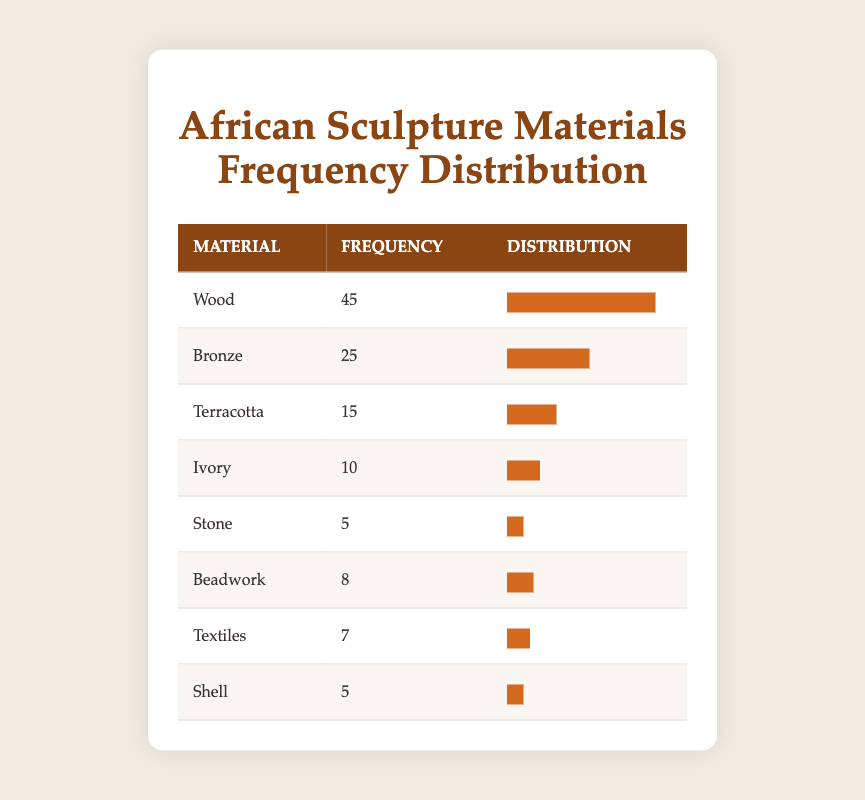What is the frequency of sculptures made from wood? The table lists wood as a material with a frequency of 45, as stated in the second row.
Answer: 45 Which material has the lowest frequency of use in traditional African sculptures? By looking at the frequencies in the table, both stone and shell are tied with a frequency of 5, indicating they are the lowest.
Answer: Stone and Shell What is the total frequency of materials listed in the table? To find the total frequency, we add the frequencies: 45 (Wood) + 25 (Bronze) + 15 (Terracotta) + 10 (Ivory) + 5 (Stone) + 8 (Beadwork) + 7 (Textiles) + 5 (Shell) = 115.
Answer: 115 Is it true that more sculptures are made from bronze than from terracotta? The frequency for bronze is 25, and for terracotta, it's 15. Since 25 is greater than 15, the statement is true.
Answer: Yes What is the percentage of sculptures made from ivory compared to the total frequency? The frequency for ivory is 10. To find the percentage, we use the formula (10 / 115) * 100, which equals approximately 8.7%.
Answer: 8.7% How many more sculptures are made from wood than from beadwork? The frequency for wood is 45, and for beadwork, it's 8. We can take the difference: 45 - 8 = 37.
Answer: 37 What is the average frequency of the materials used for sculptures? To calculate the average, sum all frequencies (45 + 25 + 15 + 10 + 5 + 8 + 7 + 5 = 115), then divide by the number of materials (8): 115 / 8 = 14.375.
Answer: 14.375 If we combine the frequencies of stone and shell, what is the total? The frequency for stone is 5, and for shell is also 5. Adding both gives: 5 + 5 = 10.
Answer: 10 Which material has a frequency greater than 20? Referring to the table, wood (45) and bronze (25) both have frequencies greater than 20.
Answer: Wood and Bronze 